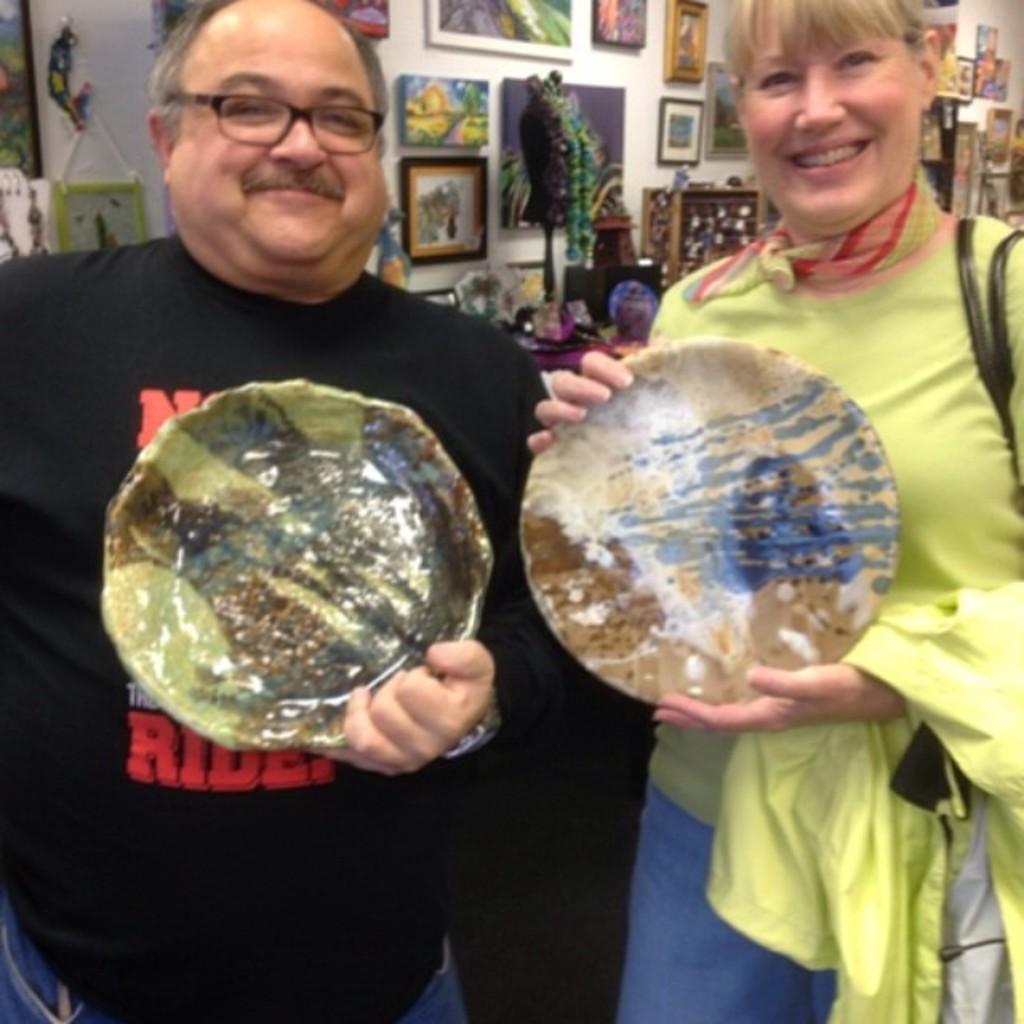Please provide a concise description of this image. In this image there are two persons in the middle who are holding the plate. There is a girl on the right side and a man on the left side. In the background there is a wall on which there are photo frames. 